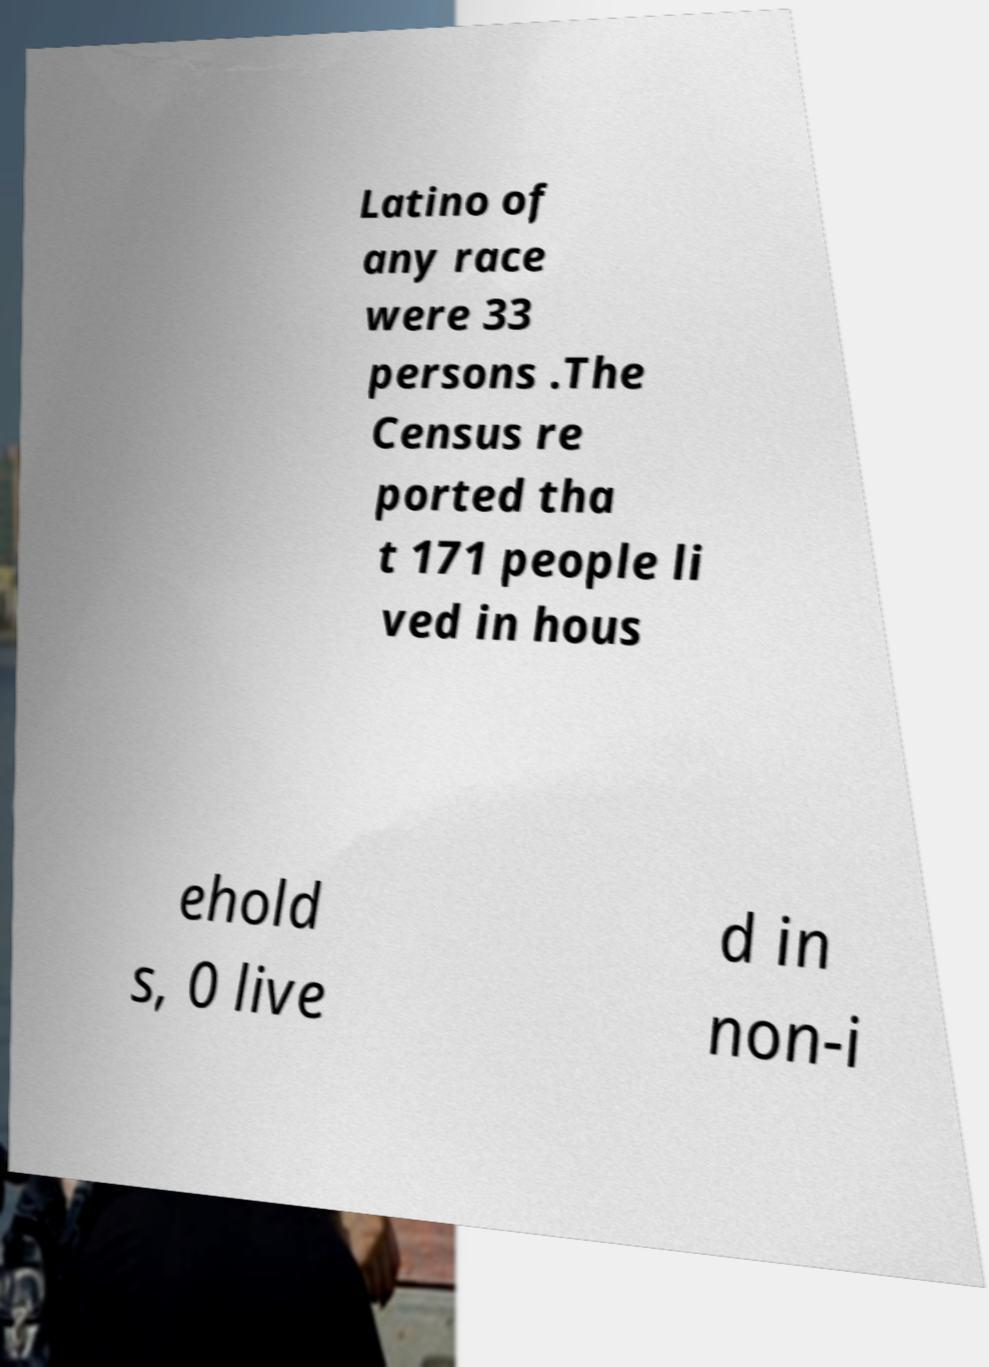Can you read and provide the text displayed in the image?This photo seems to have some interesting text. Can you extract and type it out for me? Latino of any race were 33 persons .The Census re ported tha t 171 people li ved in hous ehold s, 0 live d in non-i 